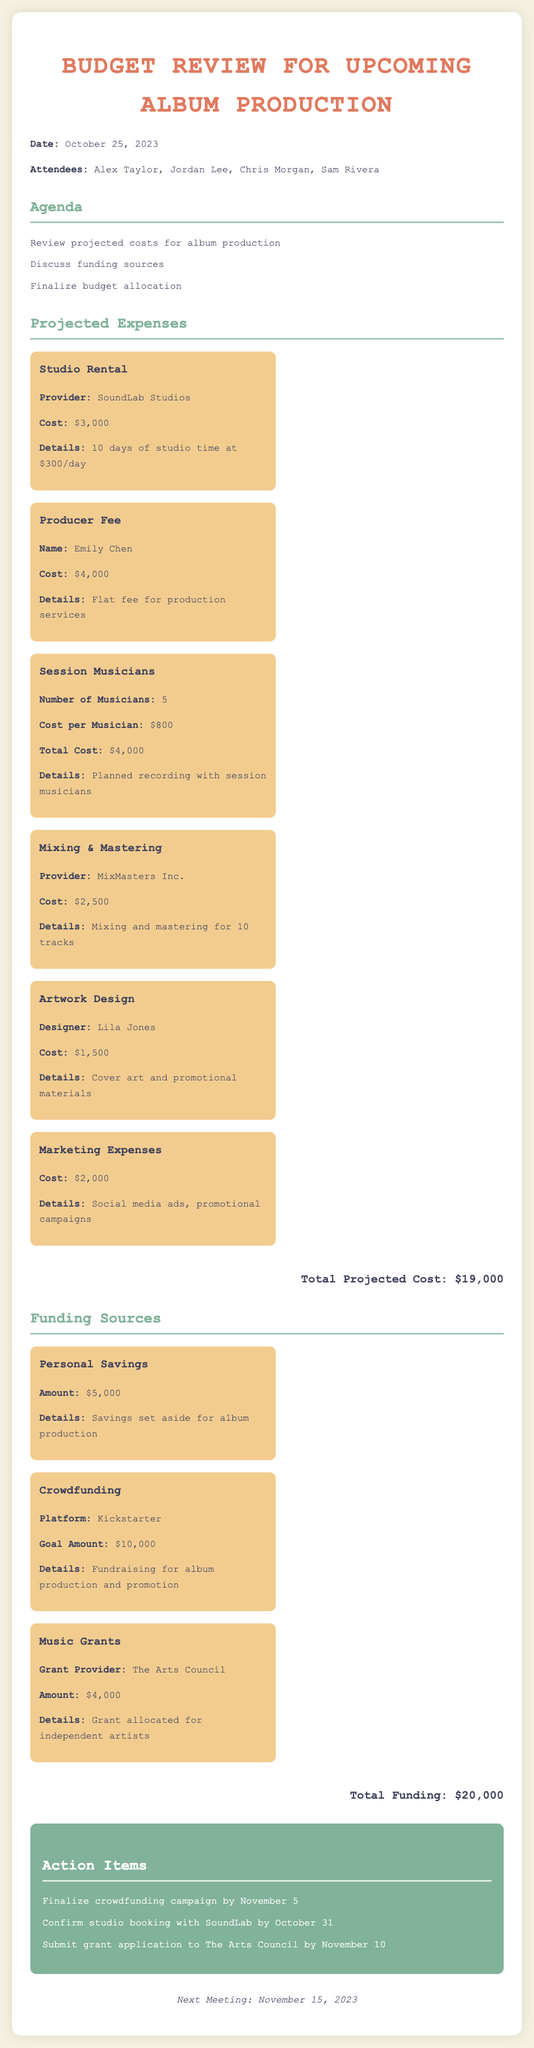What is the date of the meeting? The document states that the date of the meeting is mentioned in a paragraph, which is October 25, 2023.
Answer: October 25, 2023 Who is the producer? The document lists the producer's name and fee under projected expenses, which is Emily Chen.
Answer: Emily Chen What is the total projected cost? The total projected cost is calculated and displayed at the end of the projected expenses section in the document, which is $19,000.
Answer: $19,000 How much funding is expected from crowdfunding? The document specifies the goal amount for crowdfunding which is $10,000.
Answer: $10,000 What is the name of the studio? The studio rental expense details are provided in the document, identifying the studio as SoundLab Studios.
Answer: SoundLab Studios How many session musicians are planned? The document indicates the number of session musicians planned under the session musicians expense section, which is 5.
Answer: 5 What is the amount from personal savings? The personal savings funding source is mentioned in the document, which states the amount is $5,000.
Answer: $5,000 When is the next meeting scheduled? The document includes a section about the next meeting, stating the date as November 15, 2023.
Answer: November 15, 2023 What is the goal of the crowdfunding campaign? The document describes the crowdfunding goal in the funding sources section, which is for album production and promotion.
Answer: Album production and promotion 